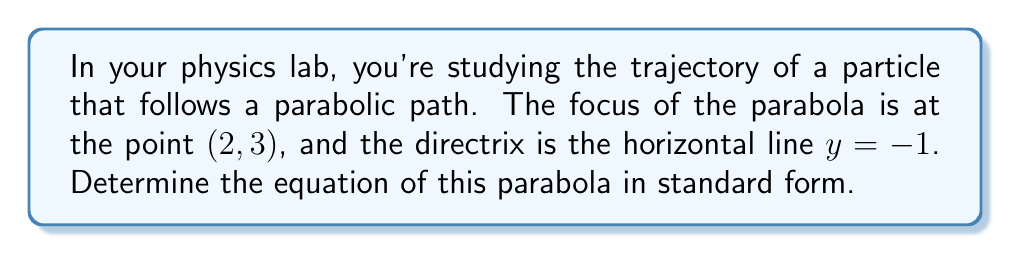Provide a solution to this math problem. Let's approach this step-by-step:

1) The general equation of a parabola with a vertical axis of symmetry is:

   $$(x - h)^2 = 4p(y - k)$$

   where (h, k) is the vertex and p is the distance from the vertex to the focus.

2) We know the focus is at (2, 3) and the directrix is y = -1. The vertex is halfway between the focus and the directrix.

3) To find the y-coordinate of the vertex:
   $$k = \frac{3 + (-1)}{2} = 1$$

4) The x-coordinate of the vertex is the same as the focus:
   $$h = 2$$

5) The distance p is half the distance between the focus and the directrix:
   $$p = \frac{3 - (-1)}{2} = 2$$

6) Now we can substitute these values into our general equation:

   $$(x - 2)^2 = 4(2)(y - 1)$$

7) Simplify:
   $$(x - 2)^2 = 8(y - 1)$$

8) Expand:
   $$x^2 - 4x + 4 = 8y - 8$$

9) Rearrange to standard form $(ax^2 + bx + cy + d = 0)$:
   $$x^2 - 4x - 8y + 12 = 0$$

[asy]
import geometry;

size(200);
real f(real x) {return (x^2-4x+12)/8;}
path p=graph(f,-1,5);
draw(p,blue);
dot((2,3),red);
draw((-1,-1)--(5,-1),dashed);
label("Focus (2,3)",(2,3),NE);
label("Directrix y=-1",(5,-1),E);
[/asy]
Answer: $$x^2 - 4x - 8y + 12 = 0$$ 